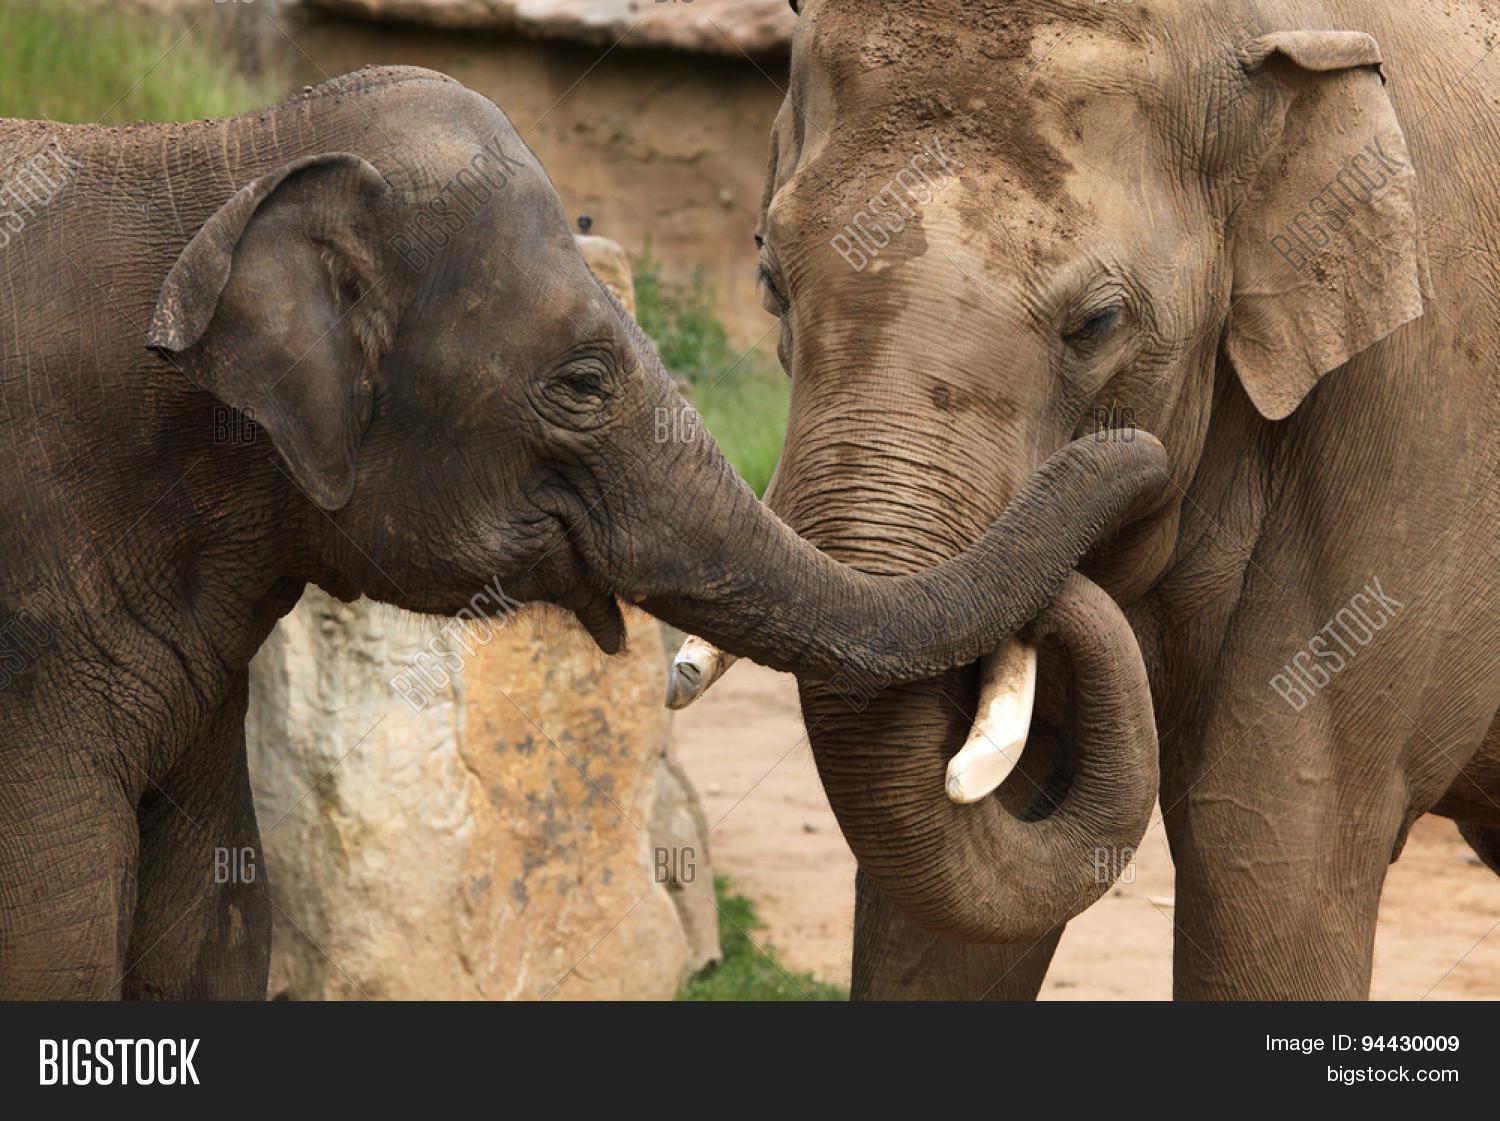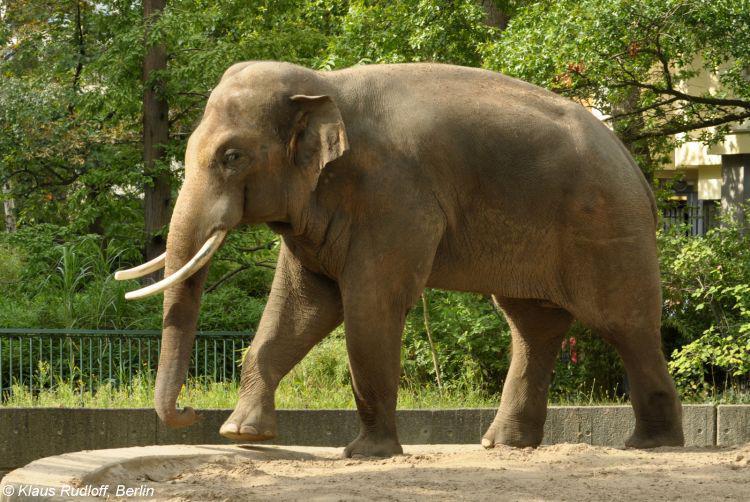The first image is the image on the left, the second image is the image on the right. For the images shown, is this caption "there is one elephant on the left image" true? Answer yes or no. No. 